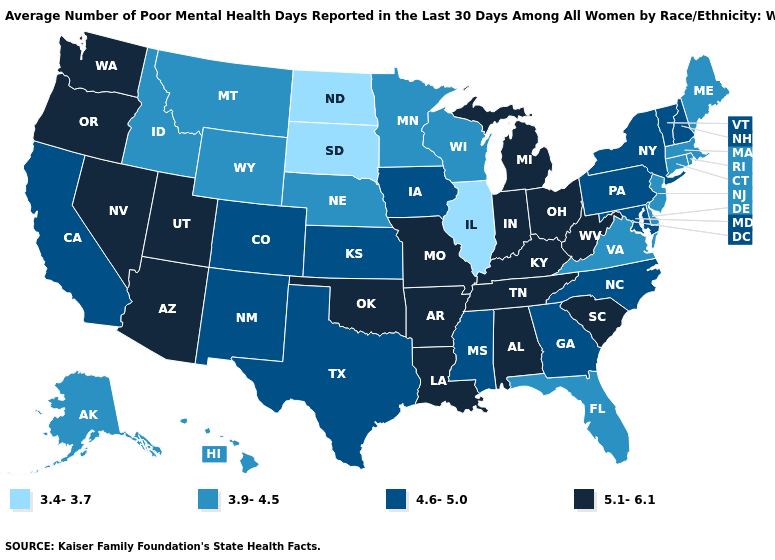Among the states that border Indiana , which have the lowest value?
Be succinct. Illinois. What is the lowest value in the West?
Answer briefly. 3.9-4.5. Which states have the lowest value in the South?
Be succinct. Delaware, Florida, Virginia. What is the lowest value in the West?
Be succinct. 3.9-4.5. Does the map have missing data?
Short answer required. No. Which states have the highest value in the USA?
Quick response, please. Alabama, Arizona, Arkansas, Indiana, Kentucky, Louisiana, Michigan, Missouri, Nevada, Ohio, Oklahoma, Oregon, South Carolina, Tennessee, Utah, Washington, West Virginia. What is the value of Arkansas?
Be succinct. 5.1-6.1. What is the value of Kansas?
Give a very brief answer. 4.6-5.0. What is the highest value in the MidWest ?
Be succinct. 5.1-6.1. Which states have the lowest value in the USA?
Answer briefly. Illinois, North Dakota, South Dakota. Does Florida have the lowest value in the South?
Write a very short answer. Yes. Name the states that have a value in the range 5.1-6.1?
Concise answer only. Alabama, Arizona, Arkansas, Indiana, Kentucky, Louisiana, Michigan, Missouri, Nevada, Ohio, Oklahoma, Oregon, South Carolina, Tennessee, Utah, Washington, West Virginia. What is the value of Arkansas?
Short answer required. 5.1-6.1. Name the states that have a value in the range 3.9-4.5?
Quick response, please. Alaska, Connecticut, Delaware, Florida, Hawaii, Idaho, Maine, Massachusetts, Minnesota, Montana, Nebraska, New Jersey, Rhode Island, Virginia, Wisconsin, Wyoming. Among the states that border Michigan , does Indiana have the lowest value?
Quick response, please. No. 